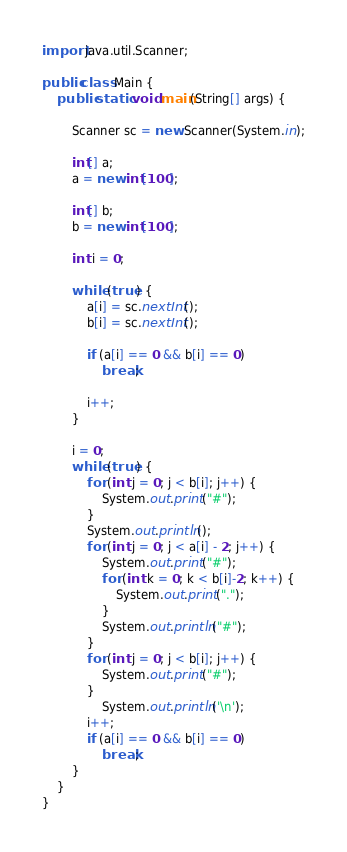<code> <loc_0><loc_0><loc_500><loc_500><_Java_>import java.util.Scanner;

public class Main {
    public static void main(String[] args) {

        Scanner sc = new Scanner(System.in);

        int[] a;
        a = new int[100];

        int[] b;
        b = new int[100];

        int i = 0;

        while (true) {
            a[i] = sc.nextInt();
            b[i] = sc.nextInt();

            if (a[i] == 0 && b[i] == 0)
                break;

            i++;
        }

        i = 0;
        while (true) {
            for (int j = 0; j < b[i]; j++) {
                System.out.print("#");
            }
            System.out.println();
            for (int j = 0; j < a[i] - 2; j++) {
                System.out.print("#");
                for (int k = 0; k < b[i]-2; k++) {
                    System.out.print(".");
                }
                System.out.println("#");
            }
            for (int j = 0; j < b[i]; j++) {
                System.out.print("#");
            }
                System.out.println('\n');
            i++;
            if (a[i] == 0 && b[i] == 0)
                break;
        }
    }
}

</code> 